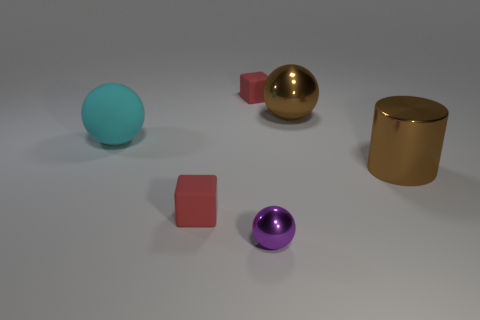How many red cubes must be subtracted to get 1 red cubes? 1 Subtract all cyan rubber spheres. How many spheres are left? 2 Add 1 blue things. How many objects exist? 7 Subtract all purple balls. How many balls are left? 2 Subtract all green cylinders. Subtract all red blocks. How many cylinders are left? 1 Add 5 tiny green cylinders. How many tiny green cylinders exist? 5 Subtract 0 blue cylinders. How many objects are left? 6 Subtract all cylinders. How many objects are left? 5 Subtract all tiny cyan rubber blocks. Subtract all big balls. How many objects are left? 4 Add 2 tiny blocks. How many tiny blocks are left? 4 